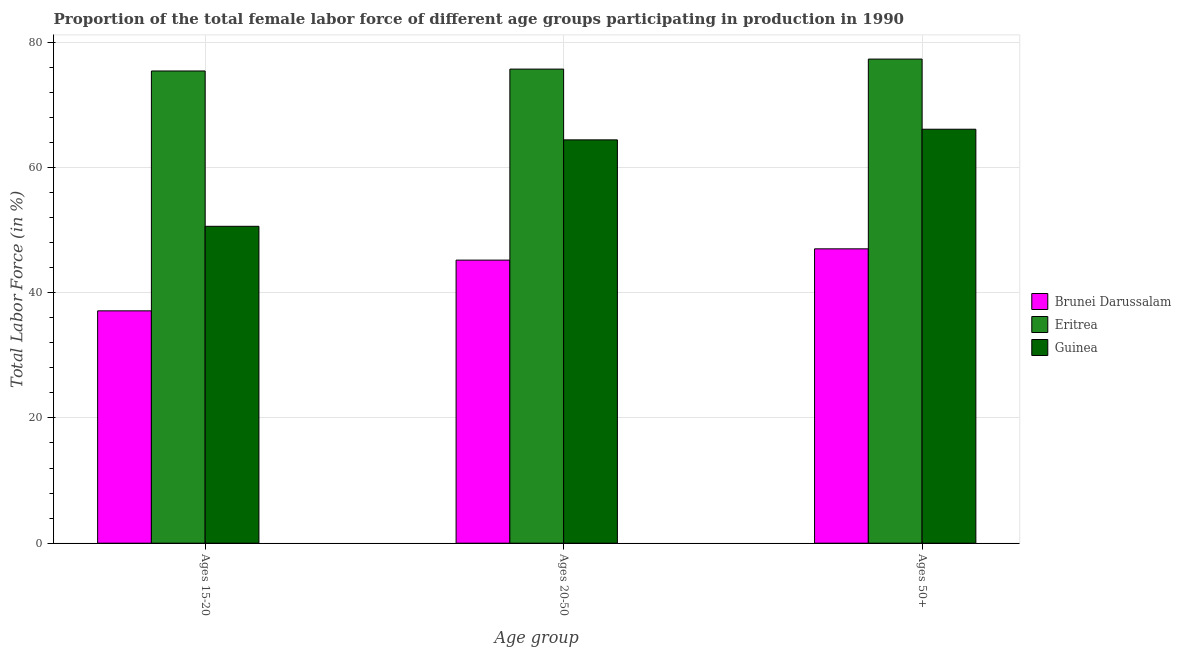How many different coloured bars are there?
Your answer should be compact. 3. How many bars are there on the 1st tick from the left?
Offer a terse response. 3. How many bars are there on the 2nd tick from the right?
Provide a succinct answer. 3. What is the label of the 2nd group of bars from the left?
Provide a succinct answer. Ages 20-50. What is the percentage of female labor force within the age group 20-50 in Guinea?
Make the answer very short. 64.4. Across all countries, what is the maximum percentage of female labor force within the age group 15-20?
Ensure brevity in your answer.  75.4. Across all countries, what is the minimum percentage of female labor force within the age group 15-20?
Your answer should be compact. 37.1. In which country was the percentage of female labor force within the age group 20-50 maximum?
Offer a terse response. Eritrea. In which country was the percentage of female labor force above age 50 minimum?
Provide a short and direct response. Brunei Darussalam. What is the total percentage of female labor force within the age group 15-20 in the graph?
Keep it short and to the point. 163.1. What is the difference between the percentage of female labor force within the age group 15-20 in Brunei Darussalam and that in Eritrea?
Keep it short and to the point. -38.3. What is the difference between the percentage of female labor force within the age group 15-20 in Guinea and the percentage of female labor force above age 50 in Eritrea?
Ensure brevity in your answer.  -26.7. What is the average percentage of female labor force above age 50 per country?
Offer a terse response. 63.47. What is the difference between the percentage of female labor force within the age group 15-20 and percentage of female labor force above age 50 in Eritrea?
Your answer should be compact. -1.9. In how many countries, is the percentage of female labor force within the age group 15-20 greater than 8 %?
Provide a short and direct response. 3. What is the ratio of the percentage of female labor force within the age group 15-20 in Brunei Darussalam to that in Guinea?
Give a very brief answer. 0.73. Is the percentage of female labor force within the age group 20-50 in Guinea less than that in Brunei Darussalam?
Provide a short and direct response. No. What is the difference between the highest and the second highest percentage of female labor force within the age group 20-50?
Your answer should be compact. 11.3. What is the difference between the highest and the lowest percentage of female labor force within the age group 15-20?
Your response must be concise. 38.3. Is the sum of the percentage of female labor force within the age group 20-50 in Brunei Darussalam and Eritrea greater than the maximum percentage of female labor force within the age group 15-20 across all countries?
Offer a terse response. Yes. What does the 1st bar from the left in Ages 20-50 represents?
Your answer should be very brief. Brunei Darussalam. What does the 2nd bar from the right in Ages 20-50 represents?
Make the answer very short. Eritrea. Is it the case that in every country, the sum of the percentage of female labor force within the age group 15-20 and percentage of female labor force within the age group 20-50 is greater than the percentage of female labor force above age 50?
Your answer should be very brief. Yes. Are all the bars in the graph horizontal?
Make the answer very short. No. What is the difference between two consecutive major ticks on the Y-axis?
Offer a very short reply. 20. Are the values on the major ticks of Y-axis written in scientific E-notation?
Offer a very short reply. No. Does the graph contain any zero values?
Keep it short and to the point. No. Does the graph contain grids?
Offer a terse response. Yes. Where does the legend appear in the graph?
Provide a short and direct response. Center right. How many legend labels are there?
Your answer should be very brief. 3. What is the title of the graph?
Keep it short and to the point. Proportion of the total female labor force of different age groups participating in production in 1990. What is the label or title of the X-axis?
Your answer should be very brief. Age group. What is the Total Labor Force (in %) in Brunei Darussalam in Ages 15-20?
Provide a succinct answer. 37.1. What is the Total Labor Force (in %) of Eritrea in Ages 15-20?
Make the answer very short. 75.4. What is the Total Labor Force (in %) in Guinea in Ages 15-20?
Offer a very short reply. 50.6. What is the Total Labor Force (in %) of Brunei Darussalam in Ages 20-50?
Ensure brevity in your answer.  45.2. What is the Total Labor Force (in %) in Eritrea in Ages 20-50?
Offer a terse response. 75.7. What is the Total Labor Force (in %) of Guinea in Ages 20-50?
Your answer should be very brief. 64.4. What is the Total Labor Force (in %) of Brunei Darussalam in Ages 50+?
Offer a very short reply. 47. What is the Total Labor Force (in %) of Eritrea in Ages 50+?
Your answer should be very brief. 77.3. What is the Total Labor Force (in %) in Guinea in Ages 50+?
Your answer should be very brief. 66.1. Across all Age group, what is the maximum Total Labor Force (in %) of Eritrea?
Provide a short and direct response. 77.3. Across all Age group, what is the maximum Total Labor Force (in %) of Guinea?
Your answer should be very brief. 66.1. Across all Age group, what is the minimum Total Labor Force (in %) in Brunei Darussalam?
Provide a short and direct response. 37.1. Across all Age group, what is the minimum Total Labor Force (in %) in Eritrea?
Keep it short and to the point. 75.4. Across all Age group, what is the minimum Total Labor Force (in %) in Guinea?
Offer a terse response. 50.6. What is the total Total Labor Force (in %) of Brunei Darussalam in the graph?
Your answer should be compact. 129.3. What is the total Total Labor Force (in %) of Eritrea in the graph?
Provide a succinct answer. 228.4. What is the total Total Labor Force (in %) of Guinea in the graph?
Give a very brief answer. 181.1. What is the difference between the Total Labor Force (in %) in Brunei Darussalam in Ages 15-20 and that in Ages 20-50?
Provide a short and direct response. -8.1. What is the difference between the Total Labor Force (in %) in Brunei Darussalam in Ages 15-20 and that in Ages 50+?
Provide a succinct answer. -9.9. What is the difference between the Total Labor Force (in %) in Guinea in Ages 15-20 and that in Ages 50+?
Your response must be concise. -15.5. What is the difference between the Total Labor Force (in %) of Brunei Darussalam in Ages 20-50 and that in Ages 50+?
Your answer should be very brief. -1.8. What is the difference between the Total Labor Force (in %) in Eritrea in Ages 20-50 and that in Ages 50+?
Give a very brief answer. -1.6. What is the difference between the Total Labor Force (in %) of Brunei Darussalam in Ages 15-20 and the Total Labor Force (in %) of Eritrea in Ages 20-50?
Your answer should be very brief. -38.6. What is the difference between the Total Labor Force (in %) of Brunei Darussalam in Ages 15-20 and the Total Labor Force (in %) of Guinea in Ages 20-50?
Your answer should be very brief. -27.3. What is the difference between the Total Labor Force (in %) in Brunei Darussalam in Ages 15-20 and the Total Labor Force (in %) in Eritrea in Ages 50+?
Ensure brevity in your answer.  -40.2. What is the difference between the Total Labor Force (in %) of Brunei Darussalam in Ages 20-50 and the Total Labor Force (in %) of Eritrea in Ages 50+?
Your response must be concise. -32.1. What is the difference between the Total Labor Force (in %) of Brunei Darussalam in Ages 20-50 and the Total Labor Force (in %) of Guinea in Ages 50+?
Your answer should be very brief. -20.9. What is the difference between the Total Labor Force (in %) of Eritrea in Ages 20-50 and the Total Labor Force (in %) of Guinea in Ages 50+?
Make the answer very short. 9.6. What is the average Total Labor Force (in %) of Brunei Darussalam per Age group?
Your response must be concise. 43.1. What is the average Total Labor Force (in %) of Eritrea per Age group?
Your answer should be very brief. 76.13. What is the average Total Labor Force (in %) in Guinea per Age group?
Make the answer very short. 60.37. What is the difference between the Total Labor Force (in %) of Brunei Darussalam and Total Labor Force (in %) of Eritrea in Ages 15-20?
Your response must be concise. -38.3. What is the difference between the Total Labor Force (in %) of Brunei Darussalam and Total Labor Force (in %) of Guinea in Ages 15-20?
Make the answer very short. -13.5. What is the difference between the Total Labor Force (in %) in Eritrea and Total Labor Force (in %) in Guinea in Ages 15-20?
Offer a very short reply. 24.8. What is the difference between the Total Labor Force (in %) of Brunei Darussalam and Total Labor Force (in %) of Eritrea in Ages 20-50?
Ensure brevity in your answer.  -30.5. What is the difference between the Total Labor Force (in %) in Brunei Darussalam and Total Labor Force (in %) in Guinea in Ages 20-50?
Give a very brief answer. -19.2. What is the difference between the Total Labor Force (in %) of Brunei Darussalam and Total Labor Force (in %) of Eritrea in Ages 50+?
Your answer should be compact. -30.3. What is the difference between the Total Labor Force (in %) in Brunei Darussalam and Total Labor Force (in %) in Guinea in Ages 50+?
Ensure brevity in your answer.  -19.1. What is the difference between the Total Labor Force (in %) in Eritrea and Total Labor Force (in %) in Guinea in Ages 50+?
Give a very brief answer. 11.2. What is the ratio of the Total Labor Force (in %) of Brunei Darussalam in Ages 15-20 to that in Ages 20-50?
Your answer should be compact. 0.82. What is the ratio of the Total Labor Force (in %) of Guinea in Ages 15-20 to that in Ages 20-50?
Offer a terse response. 0.79. What is the ratio of the Total Labor Force (in %) in Brunei Darussalam in Ages 15-20 to that in Ages 50+?
Offer a very short reply. 0.79. What is the ratio of the Total Labor Force (in %) of Eritrea in Ages 15-20 to that in Ages 50+?
Provide a short and direct response. 0.98. What is the ratio of the Total Labor Force (in %) in Guinea in Ages 15-20 to that in Ages 50+?
Give a very brief answer. 0.77. What is the ratio of the Total Labor Force (in %) in Brunei Darussalam in Ages 20-50 to that in Ages 50+?
Your response must be concise. 0.96. What is the ratio of the Total Labor Force (in %) of Eritrea in Ages 20-50 to that in Ages 50+?
Your response must be concise. 0.98. What is the ratio of the Total Labor Force (in %) of Guinea in Ages 20-50 to that in Ages 50+?
Offer a terse response. 0.97. What is the difference between the highest and the second highest Total Labor Force (in %) of Brunei Darussalam?
Provide a succinct answer. 1.8. 